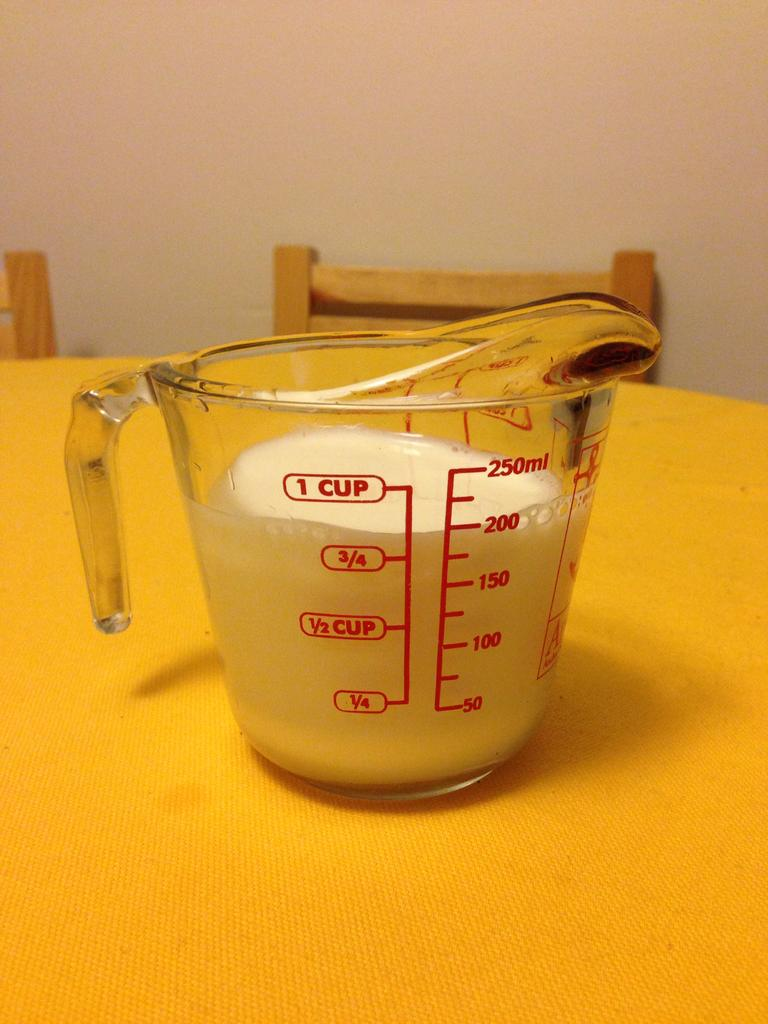<image>
Write a terse but informative summary of the picture. Measuring cup that contains measures up to one cup. 